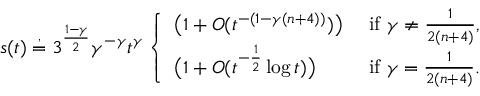<formula> <loc_0><loc_0><loc_500><loc_500>s ( t ) \stackrel { , } { = } 3 ^ { \frac { 1 - \gamma } { 2 } } \gamma ^ { - \gamma } t ^ { \gamma } \left \{ \begin{array} { l l } { \left ( 1 + O ( t ^ { - ( 1 - \gamma ( n + 4 ) ) } ) \right ) } & { i f \gamma \ne \frac { 1 } { 2 ( n + 4 ) } , } \\ { \left ( 1 + O ( t ^ { - \frac { 1 } { 2 } } \log t ) \right ) } & { i f \gamma = \frac { 1 } { 2 ( n + 4 ) } . } \end{array}</formula> 